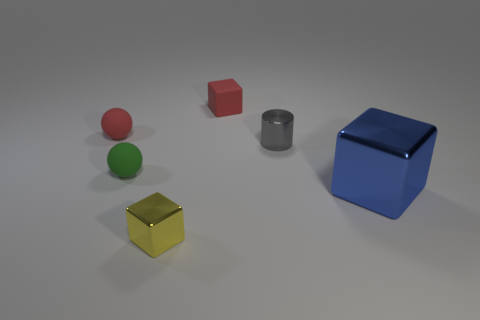What size is the red object in front of the small red matte thing that is right of the metal thing that is to the left of the gray shiny thing?
Make the answer very short. Small. How many yellow things are either spheres or tiny blocks?
Offer a very short reply. 1. What shape is the small red matte object left of the tiny shiny thing that is in front of the blue thing?
Ensure brevity in your answer.  Sphere. Does the shiny cube behind the tiny yellow metallic object have the same size as the red matte object to the right of the tiny yellow cube?
Give a very brief answer. No. Are there any small red balls that have the same material as the gray thing?
Offer a very short reply. No. There is a thing that is the same color as the matte cube; what is its size?
Provide a short and direct response. Small. There is a cube on the left side of the cube that is behind the large block; is there a small block to the left of it?
Your answer should be very brief. No. Are there any objects in front of the tiny gray shiny cylinder?
Provide a succinct answer. Yes. There is a tiny red object behind the tiny red sphere; what number of red rubber blocks are on the right side of it?
Offer a terse response. 0. Does the green sphere have the same size as the matte ball behind the cylinder?
Your answer should be compact. Yes. 